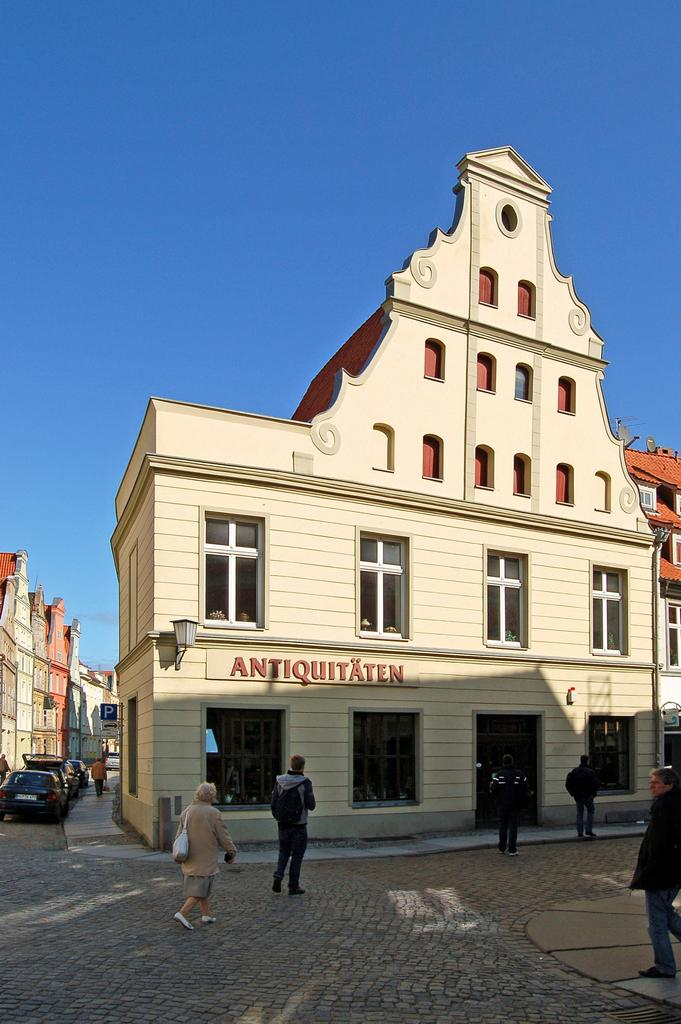<image>
Present a compact description of the photo's key features. Antiquitaten is the name shown front and center of this building. 